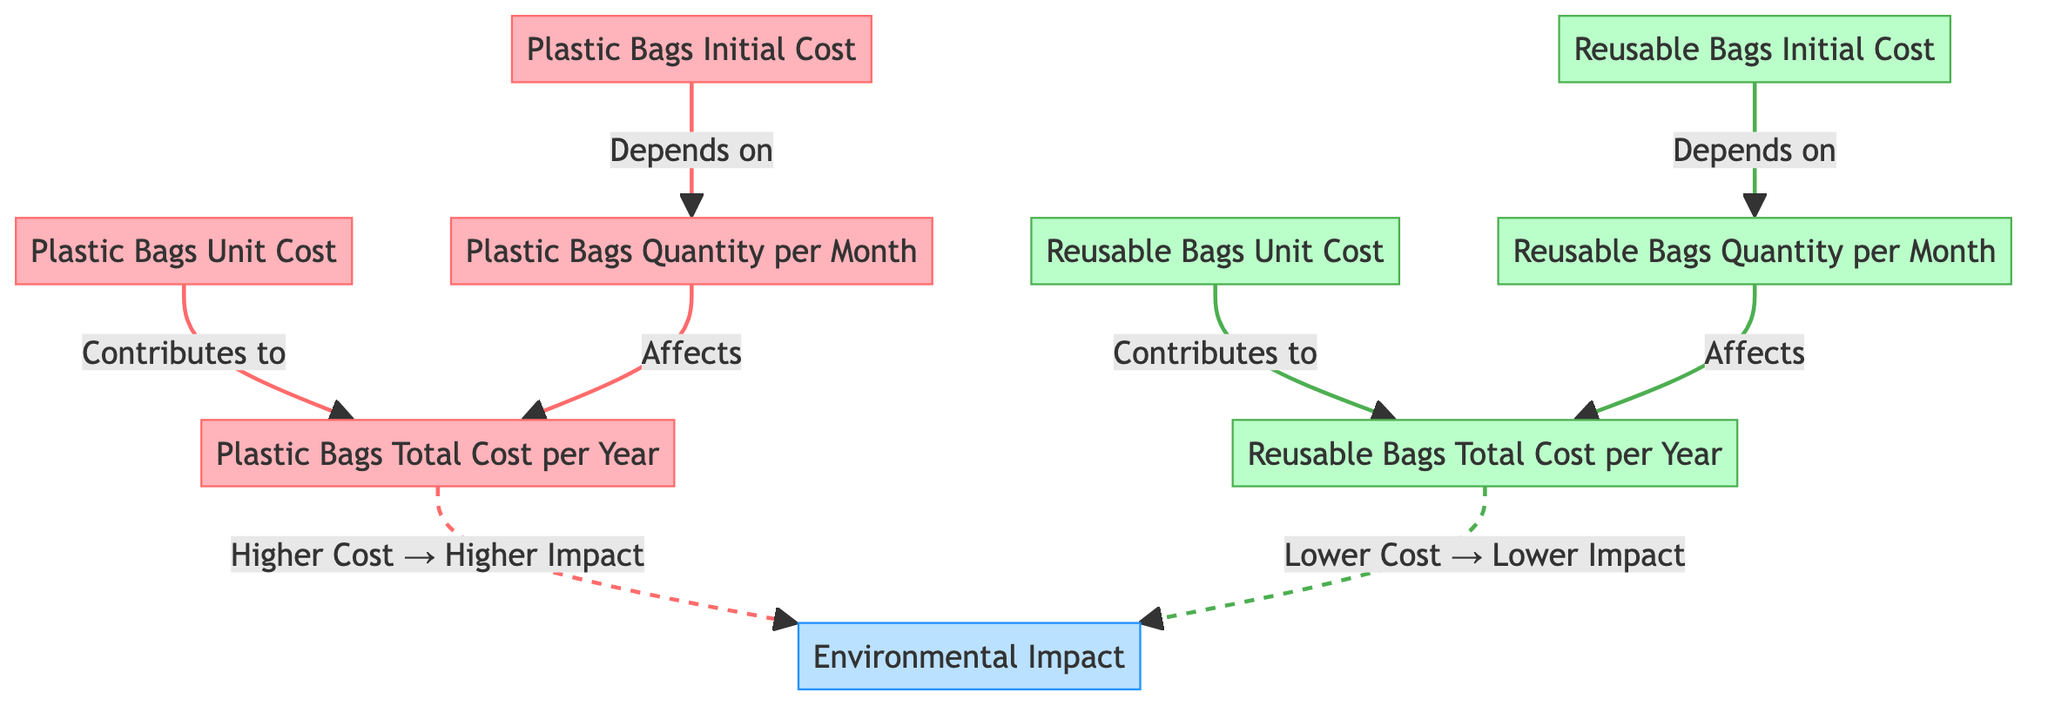What does the Plastic Bags Initial Cost depend on? The Plastic Bags Initial Cost depends on the Plastic Bags Quantity per Month, as indicated by the arrow leading from the Plastic Bags Quantity per Month to the Plastic Bags Initial Cost.
Answer: Plastic Bags Quantity per Month What impacts the total cost for Reusable Bags? The total cost for Reusable Bags is affected by the Reusable Bags Quantity per Month, which is shown by the arrow linking Reusable Bags Quantity per Month to Reusable Bags Total Cost per Year.
Answer: Reusable Bags Quantity per Month How many nodes are related to Plastic Bags? The nodes related to Plastic Bags include Plastic Bags Initial Cost, Plastic Bags Quantity per Month, Plastic Bags Unit Cost, and Plastic Bags Total Cost per Year, totaling four nodes.
Answer: Four Which costs contribute to the Plastic Bags Total Cost per Year? The costs contributing to the Plastic Bags Total Cost per Year are the Plastic Bags Initial Cost, Plastic Bags Quantity per Month, and Plastic Bags Unit Cost, as shown by their connections leading into the Total Cost node.
Answer: Three What is the relationship between the Reusable Bags Unit Cost and the Reusable Bags Total Cost per Year? The Reusable Bags Unit Cost contributes to the Reusable Bags Total Cost per Year, as shown by the direct connection leading from the Reusable Bags Unit Cost node to the Reusable Bags Total Cost per Year node.
Answer: Contributes What type of environmental impact is suggested by higher costs in plastic bags? The diagram indicates that higher costs result in a Higher Impact on the environment, as denoted by the connection from Plastic Bags Total Cost per Year leading to Environmental Impact.
Answer: Higher Impact Which type of bag shows lower costs leading to lower environmental impact? The Reusable Bags exhibit lower costs that lead to lower environmental impact, as depicted by the connecting line from Reusable Bags Total Cost per Year that points to Environmental Impact in the diagram.
Answer: Reusable Bags What distinguishes the costs in the diagram? The distinction in costs comes from the type of bags, with Plastic Bags and Reusable Bags having separate cost paths leading to their respective Total Cost per Year calculations. This is shown by colored paths and labels indicating unit costs and total costs distinctly.
Answer: Bag type distinction What is the total impact relationship for Plastic Bags? The total impact relationship for Plastic Bags is characterized by a direct correlation with higher costs leading to a corresponding higher environmental impact, shown in the diagram with arrows and labels connecting these nodes.
Answer: Higher Cost → Higher Impact 